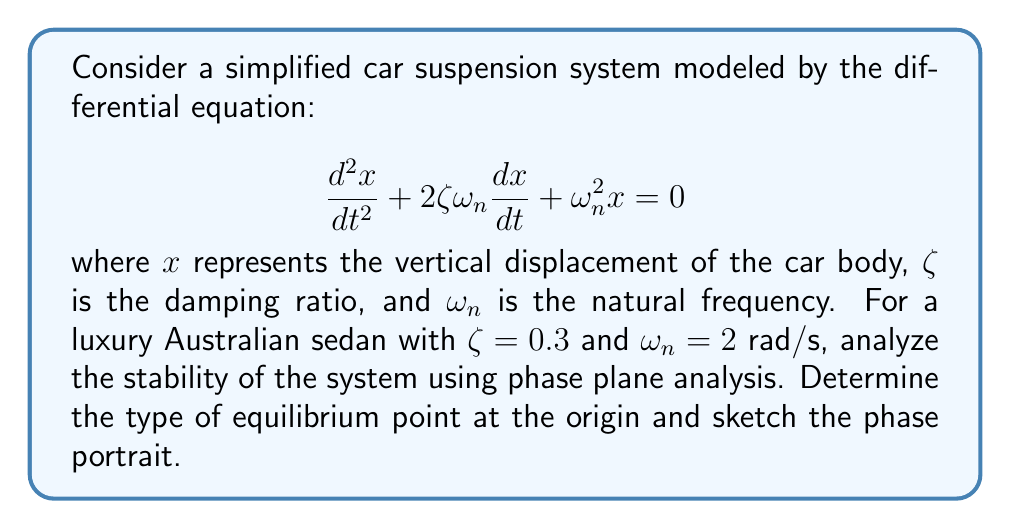Can you answer this question? To analyze the stability of the car suspension system using phase plane analysis, we'll follow these steps:

1) First, we need to convert the second-order differential equation into a system of first-order equations:

   Let $y = \frac{dx}{dt}$, then:
   
   $$\frac{dx}{dt} = y$$
   $$\frac{dy}{dt} = -\omega_n^2x - 2\zeta\omega_n y$$

2) Substituting the given values $\zeta = 0.3$ and $\omega_n = 2$ rad/s:

   $$\frac{dx}{dt} = y$$
   $$\frac{dy}{dt} = -4x - 1.2y$$

3) To determine the type of equilibrium point at the origin, we need to find the eigenvalues of the system's Jacobian matrix:

   $$J = \begin{bmatrix} 
   0 & 1 \\
   -4 & -1.2
   \end{bmatrix}$$

4) The characteristic equation is:

   $$\det(J - \lambda I) = \lambda^2 + 1.2\lambda + 4 = 0$$

5) Solving this equation:

   $$\lambda = \frac{-1.2 \pm \sqrt{1.44 - 16}}{2} = -0.6 \pm 1.8i$$

6) Since the real parts of both eigenvalues are negative and the imaginary parts are non-zero, the equilibrium point at the origin is a stable focus.

7) The phase portrait will show spiraling trajectories converging to the origin. The spirals will be tighter compared to critically damped systems, reflecting the underdamped nature of this luxury Australian sedan's suspension.

[asy]
import graph;
size(200);
xaxis("x", arrow=Arrow);
yaxis("y", arrow=Arrow);

real f(real x, real y) { return y; }
real g(real x, real y) { return -4x - 1.2y; }

add(vectorfield(f, g, (-2,-2), (2,2), 0.3));

draw((-2,0)--(2,0), gray);
draw((0,-2)--(0,2), gray);

dot((0,0));
[/asy]

This phase portrait illustrates the stable focus at the origin, with trajectories spiraling inwards, demonstrating the underdamped behavior of the suspension system.
Answer: Stable focus at the origin 